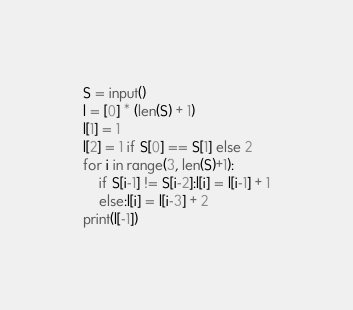<code> <loc_0><loc_0><loc_500><loc_500><_Python_>S = input()
l = [0] * (len(S) + 1)
l[1] = 1
l[2] = 1 if S[0] == S[1] else 2
for i in range(3, len(S)+1):
    if S[i-1] != S[i-2]:l[i] = l[i-1] + 1
    else:l[i] = l[i-3] + 2
print(l[-1])
</code> 